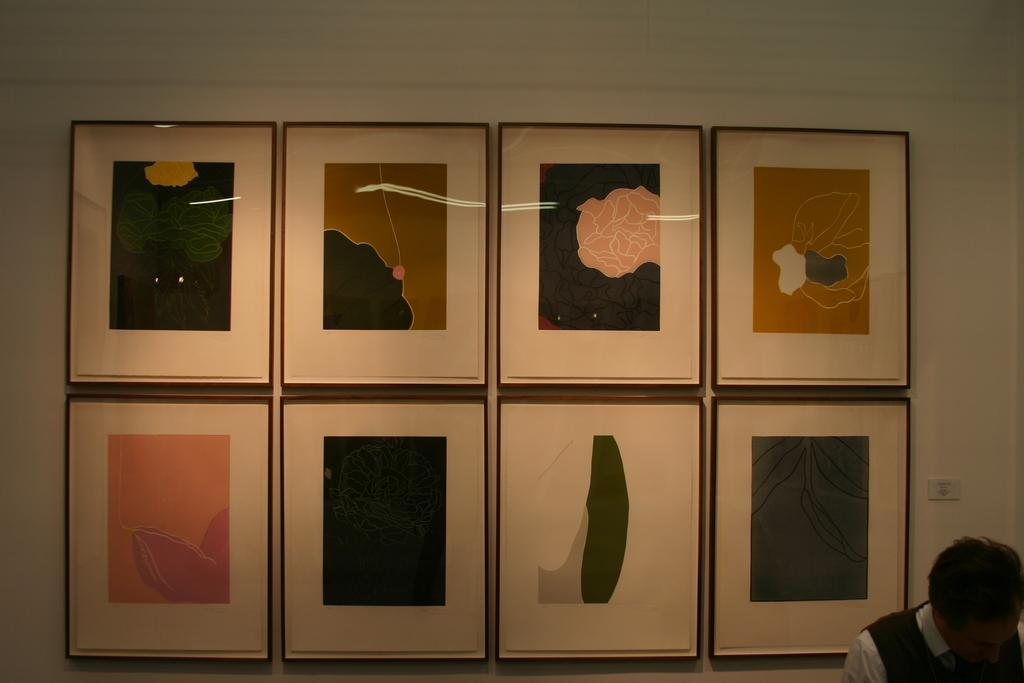What can be seen on the wall in the foreground of the image? There are frames on the wall in the foreground of the image. Can you describe the man in the image? There is a man in the right bottom corner of the image. What type of soup is the man eating in the image? There is no soup present in the image; the man is not depicted as eating anything. How many cattle are visible in the image? There are no cattle present in the image. 